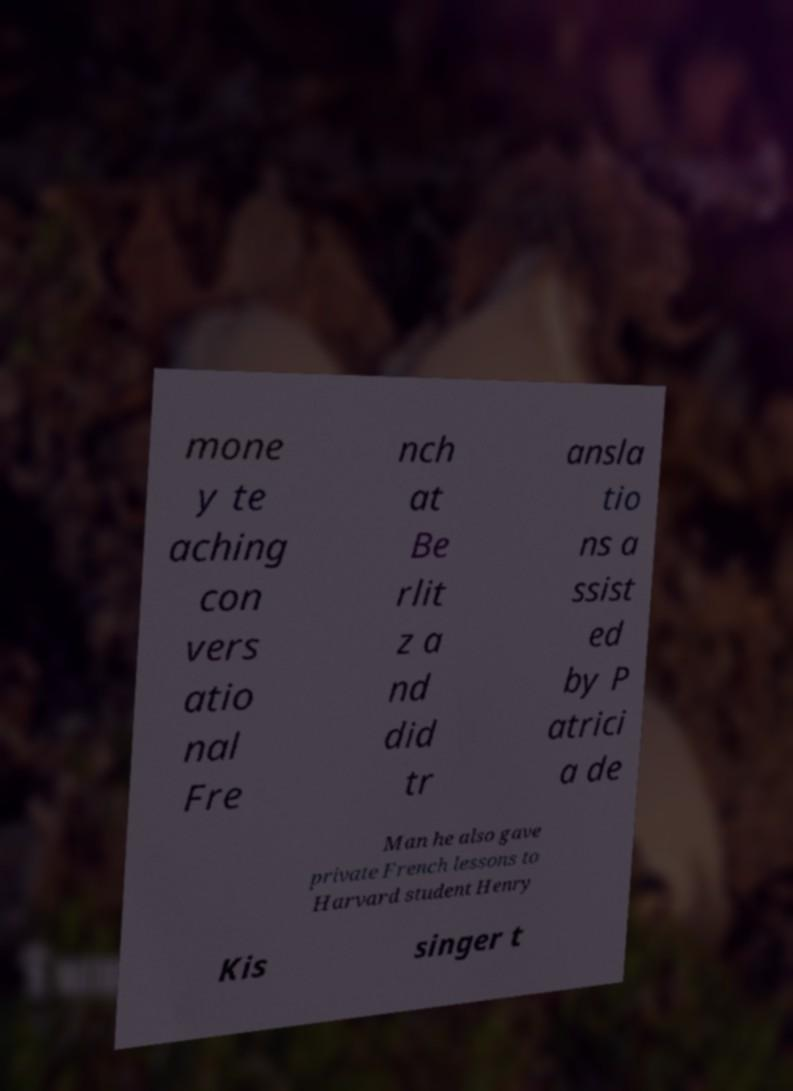I need the written content from this picture converted into text. Can you do that? mone y te aching con vers atio nal Fre nch at Be rlit z a nd did tr ansla tio ns a ssist ed by P atrici a de Man he also gave private French lessons to Harvard student Henry Kis singer t 